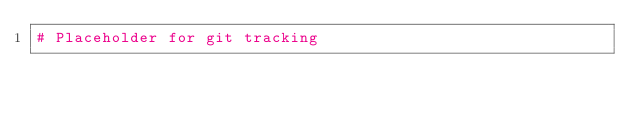Convert code to text. <code><loc_0><loc_0><loc_500><loc_500><_Python_># Placeholder for git tracking
</code> 